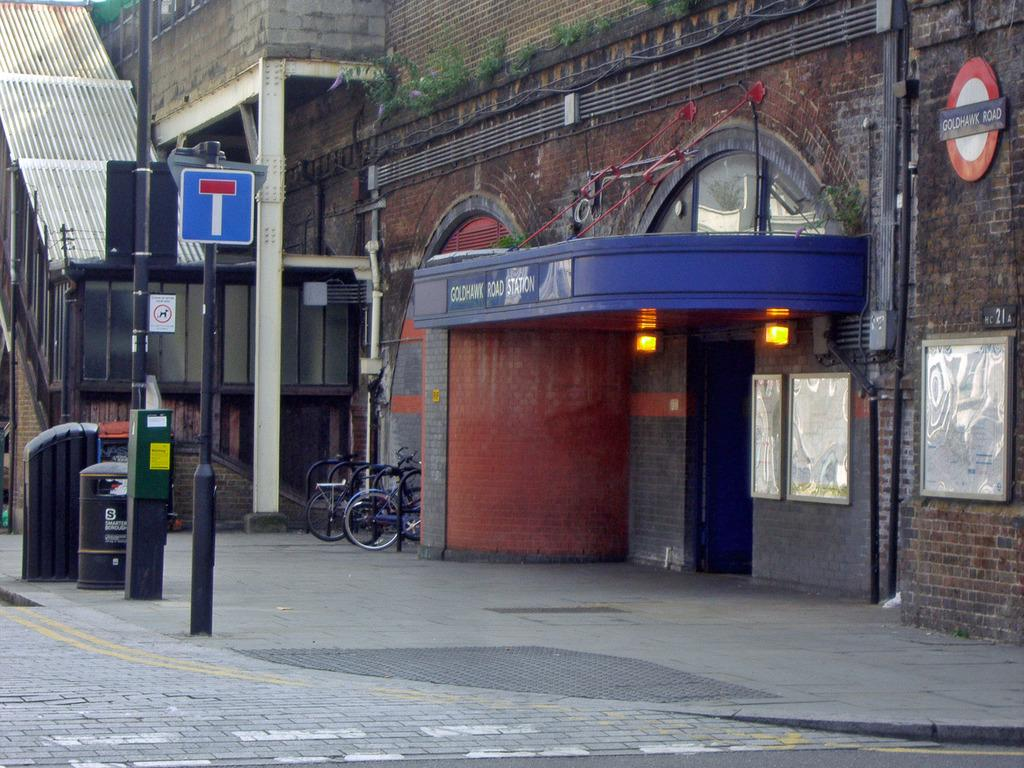What type of structure is present in the image? There is a building in the image. What other objects can be seen in the image? There are poles, a bin on the left side, bicycles, boards placed on the wall, and lights visible in the image. What type of cakes is the secretary eating in the image? There is no secretary or cakes present in the image. Can you describe the facial expressions of the people in the image? There are no people visible in the image, so facial expressions cannot be described. 